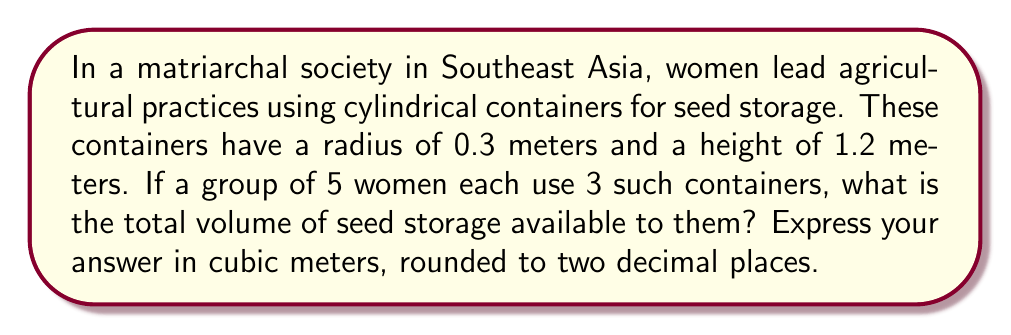Show me your answer to this math problem. To solve this problem, we need to follow these steps:

1. Calculate the volume of a single cylindrical container:
   The volume of a cylinder is given by the formula:
   $$V = \pi r^2 h$$
   where $r$ is the radius and $h$ is the height.

2. Substitute the given values:
   $$V = \pi \cdot (0.3\text{ m})^2 \cdot 1.2\text{ m}$$

3. Calculate the result:
   $$V = \pi \cdot 0.09\text{ m}^2 \cdot 1.2\text{ m} = 0.3392\text{ m}^3$$

4. Multiply by the number of containers per woman and the number of women:
   Total volume = Volume per container $\times$ Containers per woman $\times$ Number of women
   $$\text{Total volume} = 0.3392\text{ m}^3 \times 3 \times 5 = 5.088\text{ m}^3$$

5. Round to two decimal places:
   $$5.09\text{ m}^3$$

[asy]
import geometry;

size(200);
real r = 30;
real h = 120;
path p = (r,0)--(r,h)--(-r,h)--(-r,0);
path q = ellipse((0,0),r,r/4);
path s = ellipse((0,h),r,r/4);
draw(surface(p--cycle),paleblue+opacity(0.5));
draw(q);
draw(s);
draw((-r,0)--(r,0),dashed);
draw((-r,h)--(r,h),dashed);
draw((r,0)--(r,h));
draw((-r,0)--(-r,h));
label("r", (r/2,0), S);
label("h", (r,h/2), E);
[/asy]
Answer: $5.09\text{ m}^3$ 